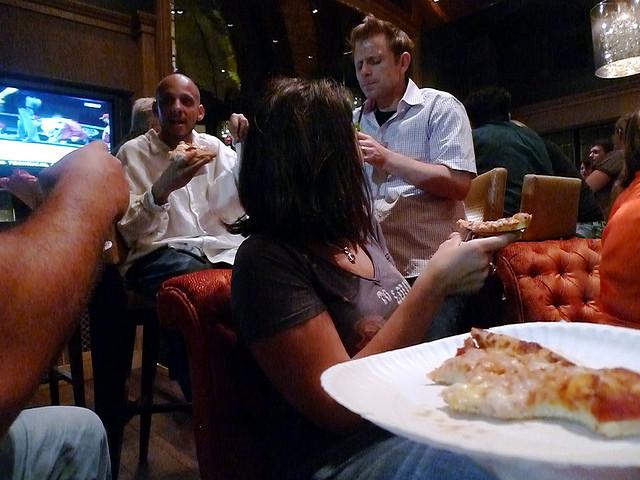Would you classify the plate with the half eaten slice as disposable?
Concise answer only. Yes. What is on the plate?
Keep it brief. Pizza. Is the TV on?
Short answer required. Yes. 